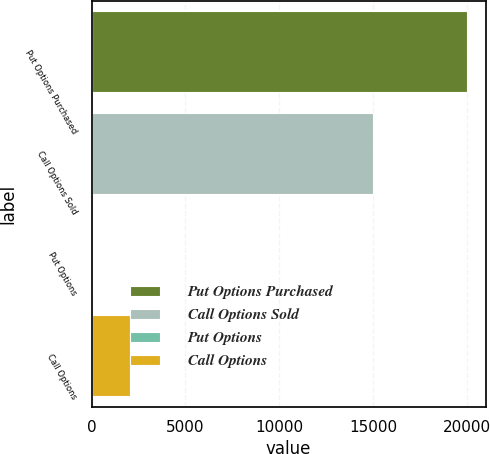Convert chart to OTSL. <chart><loc_0><loc_0><loc_500><loc_500><bar_chart><fcel>Put Options Purchased<fcel>Call Options Sold<fcel>Put Options<fcel>Call Options<nl><fcel>20000<fcel>15000<fcel>50.5<fcel>2045.45<nl></chart> 